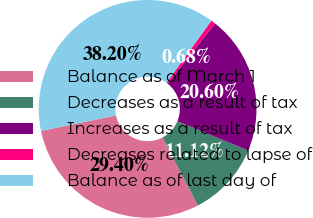<chart> <loc_0><loc_0><loc_500><loc_500><pie_chart><fcel>Balance as of March 1<fcel>Decreases as a result of tax<fcel>Increases as a result of tax<fcel>Decreases related to lapse of<fcel>Balance as of last day of<nl><fcel>29.4%<fcel>11.12%<fcel>20.6%<fcel>0.68%<fcel>38.2%<nl></chart> 